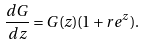<formula> <loc_0><loc_0><loc_500><loc_500>\frac { d G } { d z } = G ( z ) ( 1 + r e ^ { z } ) .</formula> 